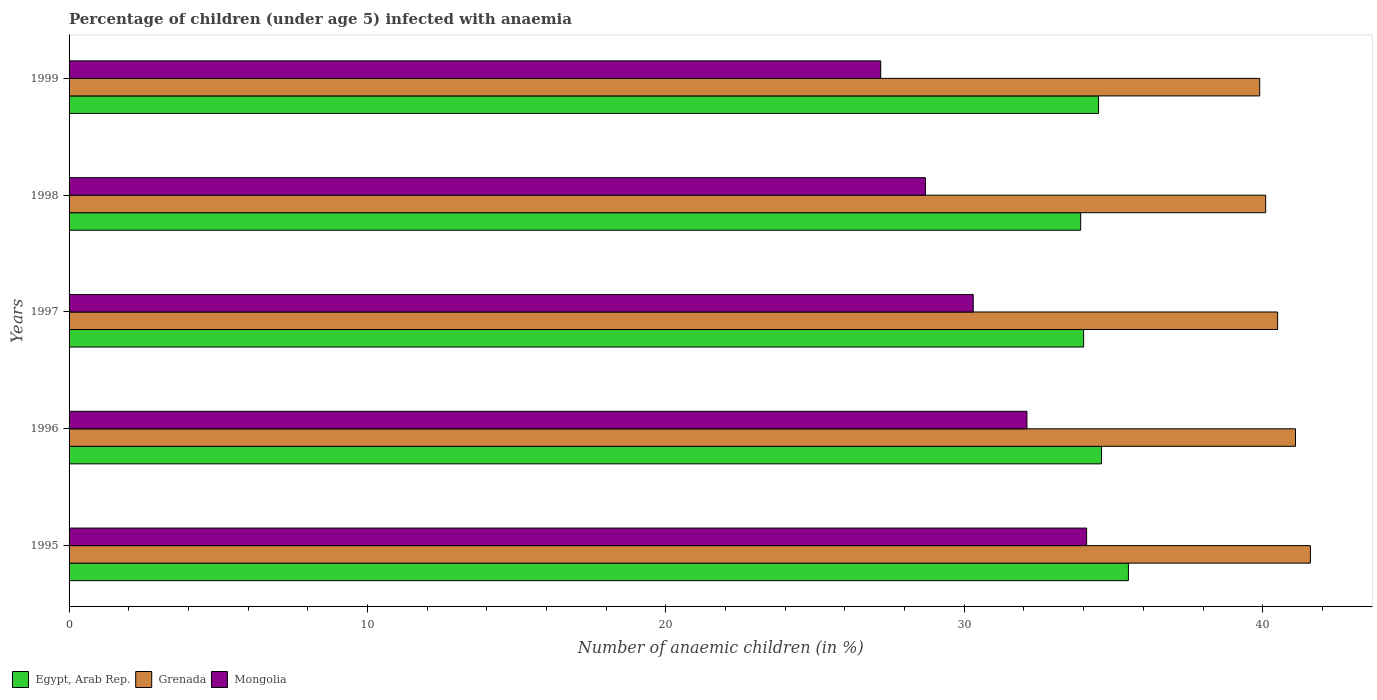How many bars are there on the 1st tick from the top?
Your answer should be very brief. 3. How many bars are there on the 2nd tick from the bottom?
Provide a succinct answer. 3. What is the label of the 5th group of bars from the top?
Make the answer very short. 1995. What is the percentage of children infected with anaemia in in Egypt, Arab Rep. in 1996?
Give a very brief answer. 34.6. Across all years, what is the maximum percentage of children infected with anaemia in in Mongolia?
Ensure brevity in your answer.  34.1. Across all years, what is the minimum percentage of children infected with anaemia in in Grenada?
Provide a succinct answer. 39.9. In which year was the percentage of children infected with anaemia in in Egypt, Arab Rep. minimum?
Make the answer very short. 1998. What is the total percentage of children infected with anaemia in in Egypt, Arab Rep. in the graph?
Offer a terse response. 172.5. What is the difference between the percentage of children infected with anaemia in in Egypt, Arab Rep. in 1998 and that in 1999?
Make the answer very short. -0.6. What is the difference between the percentage of children infected with anaemia in in Egypt, Arab Rep. in 1997 and the percentage of children infected with anaemia in in Grenada in 1999?
Provide a short and direct response. -5.9. What is the average percentage of children infected with anaemia in in Grenada per year?
Your answer should be very brief. 40.64. In the year 1999, what is the difference between the percentage of children infected with anaemia in in Grenada and percentage of children infected with anaemia in in Mongolia?
Your answer should be compact. 12.7. In how many years, is the percentage of children infected with anaemia in in Egypt, Arab Rep. greater than 24 %?
Your response must be concise. 5. What is the ratio of the percentage of children infected with anaemia in in Egypt, Arab Rep. in 1996 to that in 1997?
Provide a succinct answer. 1.02. Is the percentage of children infected with anaemia in in Grenada in 1995 less than that in 1997?
Offer a terse response. No. Is the difference between the percentage of children infected with anaemia in in Grenada in 1995 and 1998 greater than the difference between the percentage of children infected with anaemia in in Mongolia in 1995 and 1998?
Provide a short and direct response. No. What is the difference between the highest and the second highest percentage of children infected with anaemia in in Mongolia?
Offer a very short reply. 2. What is the difference between the highest and the lowest percentage of children infected with anaemia in in Grenada?
Your response must be concise. 1.7. In how many years, is the percentage of children infected with anaemia in in Grenada greater than the average percentage of children infected with anaemia in in Grenada taken over all years?
Your answer should be very brief. 2. What does the 2nd bar from the top in 1995 represents?
Offer a very short reply. Grenada. What does the 3rd bar from the bottom in 1999 represents?
Keep it short and to the point. Mongolia. How many bars are there?
Provide a short and direct response. 15. How many years are there in the graph?
Keep it short and to the point. 5. What is the difference between two consecutive major ticks on the X-axis?
Your answer should be compact. 10. Are the values on the major ticks of X-axis written in scientific E-notation?
Your answer should be compact. No. Does the graph contain grids?
Offer a very short reply. No. Where does the legend appear in the graph?
Offer a terse response. Bottom left. How many legend labels are there?
Give a very brief answer. 3. How are the legend labels stacked?
Keep it short and to the point. Horizontal. What is the title of the graph?
Make the answer very short. Percentage of children (under age 5) infected with anaemia. What is the label or title of the X-axis?
Your response must be concise. Number of anaemic children (in %). What is the label or title of the Y-axis?
Offer a terse response. Years. What is the Number of anaemic children (in %) of Egypt, Arab Rep. in 1995?
Offer a very short reply. 35.5. What is the Number of anaemic children (in %) of Grenada in 1995?
Provide a short and direct response. 41.6. What is the Number of anaemic children (in %) in Mongolia in 1995?
Ensure brevity in your answer.  34.1. What is the Number of anaemic children (in %) of Egypt, Arab Rep. in 1996?
Your answer should be very brief. 34.6. What is the Number of anaemic children (in %) of Grenada in 1996?
Offer a terse response. 41.1. What is the Number of anaemic children (in %) of Mongolia in 1996?
Provide a succinct answer. 32.1. What is the Number of anaemic children (in %) in Egypt, Arab Rep. in 1997?
Offer a very short reply. 34. What is the Number of anaemic children (in %) in Grenada in 1997?
Keep it short and to the point. 40.5. What is the Number of anaemic children (in %) of Mongolia in 1997?
Your answer should be compact. 30.3. What is the Number of anaemic children (in %) of Egypt, Arab Rep. in 1998?
Provide a short and direct response. 33.9. What is the Number of anaemic children (in %) in Grenada in 1998?
Your answer should be compact. 40.1. What is the Number of anaemic children (in %) in Mongolia in 1998?
Offer a very short reply. 28.7. What is the Number of anaemic children (in %) in Egypt, Arab Rep. in 1999?
Give a very brief answer. 34.5. What is the Number of anaemic children (in %) in Grenada in 1999?
Your answer should be very brief. 39.9. What is the Number of anaemic children (in %) of Mongolia in 1999?
Offer a very short reply. 27.2. Across all years, what is the maximum Number of anaemic children (in %) in Egypt, Arab Rep.?
Make the answer very short. 35.5. Across all years, what is the maximum Number of anaemic children (in %) of Grenada?
Your answer should be compact. 41.6. Across all years, what is the maximum Number of anaemic children (in %) in Mongolia?
Provide a short and direct response. 34.1. Across all years, what is the minimum Number of anaemic children (in %) in Egypt, Arab Rep.?
Ensure brevity in your answer.  33.9. Across all years, what is the minimum Number of anaemic children (in %) of Grenada?
Give a very brief answer. 39.9. Across all years, what is the minimum Number of anaemic children (in %) in Mongolia?
Your answer should be compact. 27.2. What is the total Number of anaemic children (in %) of Egypt, Arab Rep. in the graph?
Ensure brevity in your answer.  172.5. What is the total Number of anaemic children (in %) in Grenada in the graph?
Offer a terse response. 203.2. What is the total Number of anaemic children (in %) in Mongolia in the graph?
Make the answer very short. 152.4. What is the difference between the Number of anaemic children (in %) of Mongolia in 1995 and that in 1996?
Provide a short and direct response. 2. What is the difference between the Number of anaemic children (in %) in Egypt, Arab Rep. in 1995 and that in 1997?
Provide a short and direct response. 1.5. What is the difference between the Number of anaemic children (in %) in Grenada in 1995 and that in 1997?
Offer a very short reply. 1.1. What is the difference between the Number of anaemic children (in %) of Mongolia in 1995 and that in 1997?
Offer a very short reply. 3.8. What is the difference between the Number of anaemic children (in %) of Mongolia in 1996 and that in 1997?
Provide a short and direct response. 1.8. What is the difference between the Number of anaemic children (in %) of Egypt, Arab Rep. in 1996 and that in 1998?
Offer a very short reply. 0.7. What is the difference between the Number of anaemic children (in %) in Grenada in 1996 and that in 1998?
Offer a terse response. 1. What is the difference between the Number of anaemic children (in %) in Grenada in 1997 and that in 1998?
Ensure brevity in your answer.  0.4. What is the difference between the Number of anaemic children (in %) of Mongolia in 1997 and that in 1998?
Your response must be concise. 1.6. What is the difference between the Number of anaemic children (in %) of Egypt, Arab Rep. in 1997 and that in 1999?
Your answer should be compact. -0.5. What is the difference between the Number of anaemic children (in %) of Egypt, Arab Rep. in 1998 and that in 1999?
Provide a succinct answer. -0.6. What is the difference between the Number of anaemic children (in %) of Grenada in 1998 and that in 1999?
Offer a terse response. 0.2. What is the difference between the Number of anaemic children (in %) of Egypt, Arab Rep. in 1995 and the Number of anaemic children (in %) of Grenada in 1996?
Make the answer very short. -5.6. What is the difference between the Number of anaemic children (in %) in Egypt, Arab Rep. in 1995 and the Number of anaemic children (in %) in Mongolia in 1998?
Your answer should be compact. 6.8. What is the difference between the Number of anaemic children (in %) of Grenada in 1995 and the Number of anaemic children (in %) of Mongolia in 1998?
Offer a very short reply. 12.9. What is the difference between the Number of anaemic children (in %) in Egypt, Arab Rep. in 1995 and the Number of anaemic children (in %) in Mongolia in 1999?
Your answer should be very brief. 8.3. What is the difference between the Number of anaemic children (in %) in Egypt, Arab Rep. in 1996 and the Number of anaemic children (in %) in Grenada in 1997?
Make the answer very short. -5.9. What is the difference between the Number of anaemic children (in %) of Egypt, Arab Rep. in 1996 and the Number of anaemic children (in %) of Mongolia in 1997?
Keep it short and to the point. 4.3. What is the difference between the Number of anaemic children (in %) in Grenada in 1996 and the Number of anaemic children (in %) in Mongolia in 1997?
Provide a succinct answer. 10.8. What is the difference between the Number of anaemic children (in %) in Egypt, Arab Rep. in 1996 and the Number of anaemic children (in %) in Mongolia in 1998?
Keep it short and to the point. 5.9. What is the difference between the Number of anaemic children (in %) in Grenada in 1996 and the Number of anaemic children (in %) in Mongolia in 1998?
Provide a succinct answer. 12.4. What is the difference between the Number of anaemic children (in %) in Egypt, Arab Rep. in 1996 and the Number of anaemic children (in %) in Grenada in 1999?
Offer a terse response. -5.3. What is the difference between the Number of anaemic children (in %) in Grenada in 1996 and the Number of anaemic children (in %) in Mongolia in 1999?
Offer a terse response. 13.9. What is the difference between the Number of anaemic children (in %) in Egypt, Arab Rep. in 1997 and the Number of anaemic children (in %) in Grenada in 1998?
Ensure brevity in your answer.  -6.1. What is the difference between the Number of anaemic children (in %) in Grenada in 1997 and the Number of anaemic children (in %) in Mongolia in 1998?
Offer a terse response. 11.8. What is the difference between the Number of anaemic children (in %) in Egypt, Arab Rep. in 1997 and the Number of anaemic children (in %) in Grenada in 1999?
Your answer should be very brief. -5.9. What is the difference between the Number of anaemic children (in %) of Egypt, Arab Rep. in 1997 and the Number of anaemic children (in %) of Mongolia in 1999?
Provide a short and direct response. 6.8. What is the difference between the Number of anaemic children (in %) in Egypt, Arab Rep. in 1998 and the Number of anaemic children (in %) in Grenada in 1999?
Provide a short and direct response. -6. What is the difference between the Number of anaemic children (in %) of Egypt, Arab Rep. in 1998 and the Number of anaemic children (in %) of Mongolia in 1999?
Your answer should be very brief. 6.7. What is the difference between the Number of anaemic children (in %) of Grenada in 1998 and the Number of anaemic children (in %) of Mongolia in 1999?
Give a very brief answer. 12.9. What is the average Number of anaemic children (in %) in Egypt, Arab Rep. per year?
Offer a terse response. 34.5. What is the average Number of anaemic children (in %) of Grenada per year?
Your answer should be compact. 40.64. What is the average Number of anaemic children (in %) of Mongolia per year?
Provide a succinct answer. 30.48. In the year 1995, what is the difference between the Number of anaemic children (in %) in Egypt, Arab Rep. and Number of anaemic children (in %) in Grenada?
Offer a very short reply. -6.1. In the year 1996, what is the difference between the Number of anaemic children (in %) in Egypt, Arab Rep. and Number of anaemic children (in %) in Grenada?
Your answer should be compact. -6.5. In the year 1996, what is the difference between the Number of anaemic children (in %) of Grenada and Number of anaemic children (in %) of Mongolia?
Make the answer very short. 9. In the year 1998, what is the difference between the Number of anaemic children (in %) of Egypt, Arab Rep. and Number of anaemic children (in %) of Grenada?
Keep it short and to the point. -6.2. In the year 1999, what is the difference between the Number of anaemic children (in %) of Egypt, Arab Rep. and Number of anaemic children (in %) of Grenada?
Provide a short and direct response. -5.4. What is the ratio of the Number of anaemic children (in %) of Grenada in 1995 to that in 1996?
Provide a short and direct response. 1.01. What is the ratio of the Number of anaemic children (in %) of Mongolia in 1995 to that in 1996?
Give a very brief answer. 1.06. What is the ratio of the Number of anaemic children (in %) of Egypt, Arab Rep. in 1995 to that in 1997?
Your answer should be very brief. 1.04. What is the ratio of the Number of anaemic children (in %) of Grenada in 1995 to that in 1997?
Provide a short and direct response. 1.03. What is the ratio of the Number of anaemic children (in %) in Mongolia in 1995 to that in 1997?
Your answer should be compact. 1.13. What is the ratio of the Number of anaemic children (in %) in Egypt, Arab Rep. in 1995 to that in 1998?
Make the answer very short. 1.05. What is the ratio of the Number of anaemic children (in %) in Grenada in 1995 to that in 1998?
Provide a succinct answer. 1.04. What is the ratio of the Number of anaemic children (in %) of Mongolia in 1995 to that in 1998?
Offer a very short reply. 1.19. What is the ratio of the Number of anaemic children (in %) in Egypt, Arab Rep. in 1995 to that in 1999?
Keep it short and to the point. 1.03. What is the ratio of the Number of anaemic children (in %) in Grenada in 1995 to that in 1999?
Your answer should be very brief. 1.04. What is the ratio of the Number of anaemic children (in %) in Mongolia in 1995 to that in 1999?
Offer a terse response. 1.25. What is the ratio of the Number of anaemic children (in %) of Egypt, Arab Rep. in 1996 to that in 1997?
Keep it short and to the point. 1.02. What is the ratio of the Number of anaemic children (in %) in Grenada in 1996 to that in 1997?
Your answer should be compact. 1.01. What is the ratio of the Number of anaemic children (in %) in Mongolia in 1996 to that in 1997?
Your answer should be compact. 1.06. What is the ratio of the Number of anaemic children (in %) in Egypt, Arab Rep. in 1996 to that in 1998?
Make the answer very short. 1.02. What is the ratio of the Number of anaemic children (in %) in Grenada in 1996 to that in 1998?
Offer a terse response. 1.02. What is the ratio of the Number of anaemic children (in %) in Mongolia in 1996 to that in 1998?
Provide a short and direct response. 1.12. What is the ratio of the Number of anaemic children (in %) of Grenada in 1996 to that in 1999?
Your answer should be very brief. 1.03. What is the ratio of the Number of anaemic children (in %) of Mongolia in 1996 to that in 1999?
Make the answer very short. 1.18. What is the ratio of the Number of anaemic children (in %) of Egypt, Arab Rep. in 1997 to that in 1998?
Your response must be concise. 1. What is the ratio of the Number of anaemic children (in %) in Mongolia in 1997 to that in 1998?
Your answer should be compact. 1.06. What is the ratio of the Number of anaemic children (in %) in Egypt, Arab Rep. in 1997 to that in 1999?
Your response must be concise. 0.99. What is the ratio of the Number of anaemic children (in %) of Grenada in 1997 to that in 1999?
Keep it short and to the point. 1.01. What is the ratio of the Number of anaemic children (in %) of Mongolia in 1997 to that in 1999?
Ensure brevity in your answer.  1.11. What is the ratio of the Number of anaemic children (in %) in Egypt, Arab Rep. in 1998 to that in 1999?
Ensure brevity in your answer.  0.98. What is the ratio of the Number of anaemic children (in %) of Grenada in 1998 to that in 1999?
Ensure brevity in your answer.  1. What is the ratio of the Number of anaemic children (in %) of Mongolia in 1998 to that in 1999?
Offer a very short reply. 1.06. What is the difference between the highest and the second highest Number of anaemic children (in %) of Egypt, Arab Rep.?
Offer a very short reply. 0.9. What is the difference between the highest and the second highest Number of anaemic children (in %) in Grenada?
Your response must be concise. 0.5. What is the difference between the highest and the second highest Number of anaemic children (in %) in Mongolia?
Make the answer very short. 2. What is the difference between the highest and the lowest Number of anaemic children (in %) of Egypt, Arab Rep.?
Offer a terse response. 1.6. What is the difference between the highest and the lowest Number of anaemic children (in %) of Grenada?
Provide a succinct answer. 1.7. 